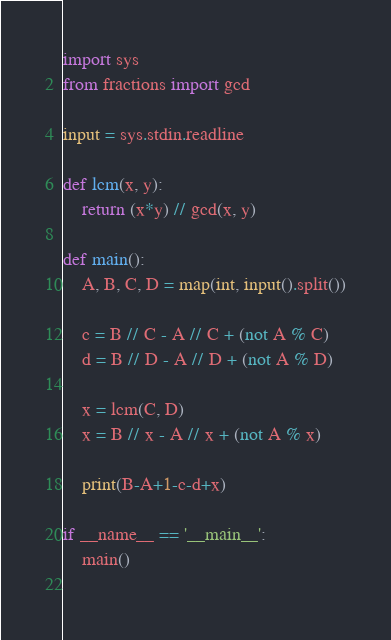Convert code to text. <code><loc_0><loc_0><loc_500><loc_500><_Python_>import sys
from fractions import gcd

input = sys.stdin.readline

def lcm(x, y):
    return (x*y) // gcd(x, y)

def main():
    A, B, C, D = map(int, input().split())
    
    c = B // C - A // C + (not A % C)
    d = B // D - A // D + (not A % D)
    
    x = lcm(C, D)
    x = B // x - A // x + (not A % x)
    
    print(B-A+1-c-d+x)
    
if __name__ == '__main__':
    main()
    </code> 